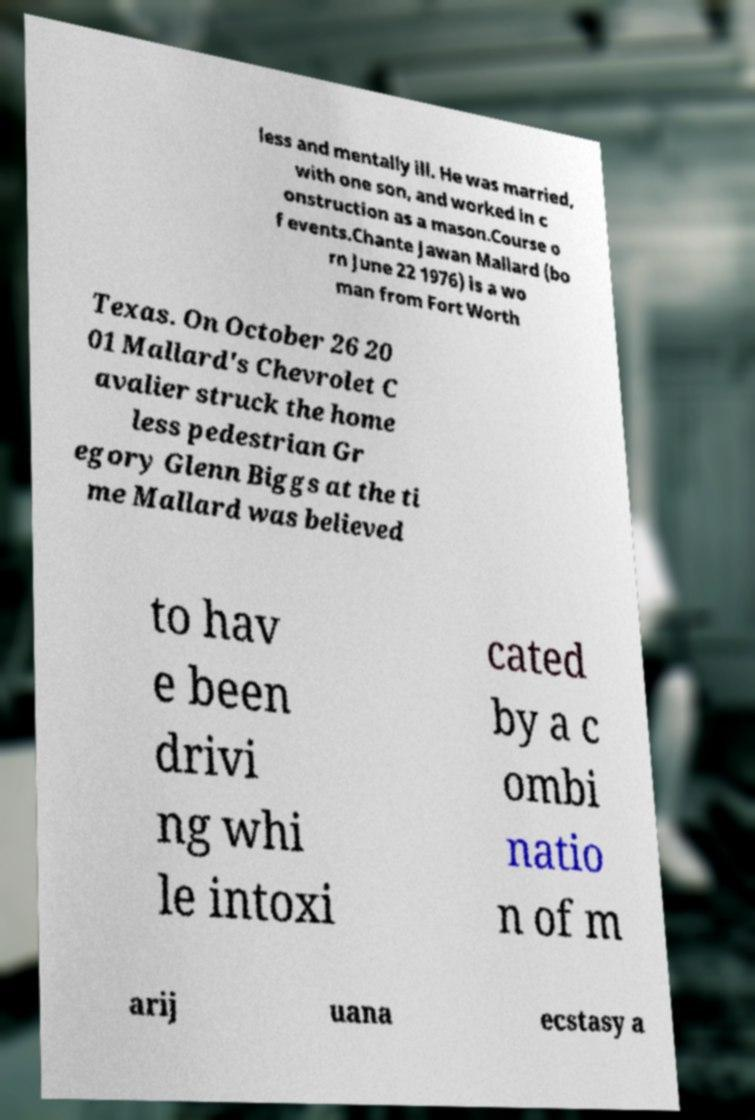What messages or text are displayed in this image? I need them in a readable, typed format. less and mentally ill. He was married, with one son, and worked in c onstruction as a mason.Course o f events.Chante Jawan Mallard (bo rn June 22 1976) is a wo man from Fort Worth Texas. On October 26 20 01 Mallard's Chevrolet C avalier struck the home less pedestrian Gr egory Glenn Biggs at the ti me Mallard was believed to hav e been drivi ng whi le intoxi cated by a c ombi natio n of m arij uana ecstasy a 